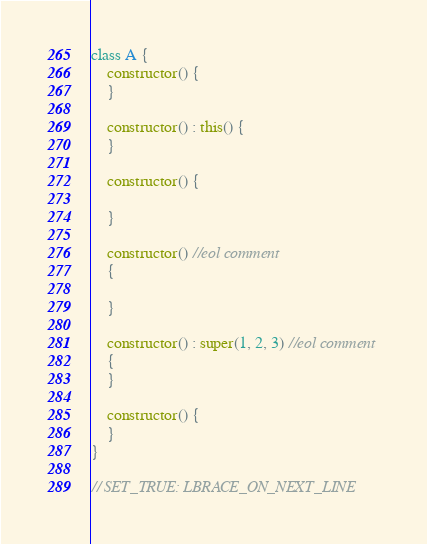Convert code to text. <code><loc_0><loc_0><loc_500><loc_500><_Kotlin_>class A {
    constructor() {
    }

    constructor() : this() {
    }

    constructor() {

    }

    constructor() //eol comment
    {

    }

    constructor() : super(1, 2, 3) //eol comment
    {
    }

    constructor() {
    }
}

// SET_TRUE: LBRACE_ON_NEXT_LINE
</code> 